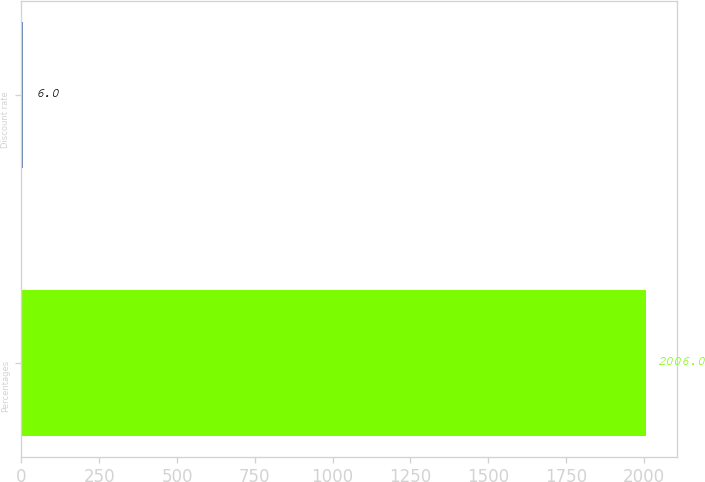Convert chart to OTSL. <chart><loc_0><loc_0><loc_500><loc_500><bar_chart><fcel>Percentages<fcel>Discount rate<nl><fcel>2006<fcel>6<nl></chart> 